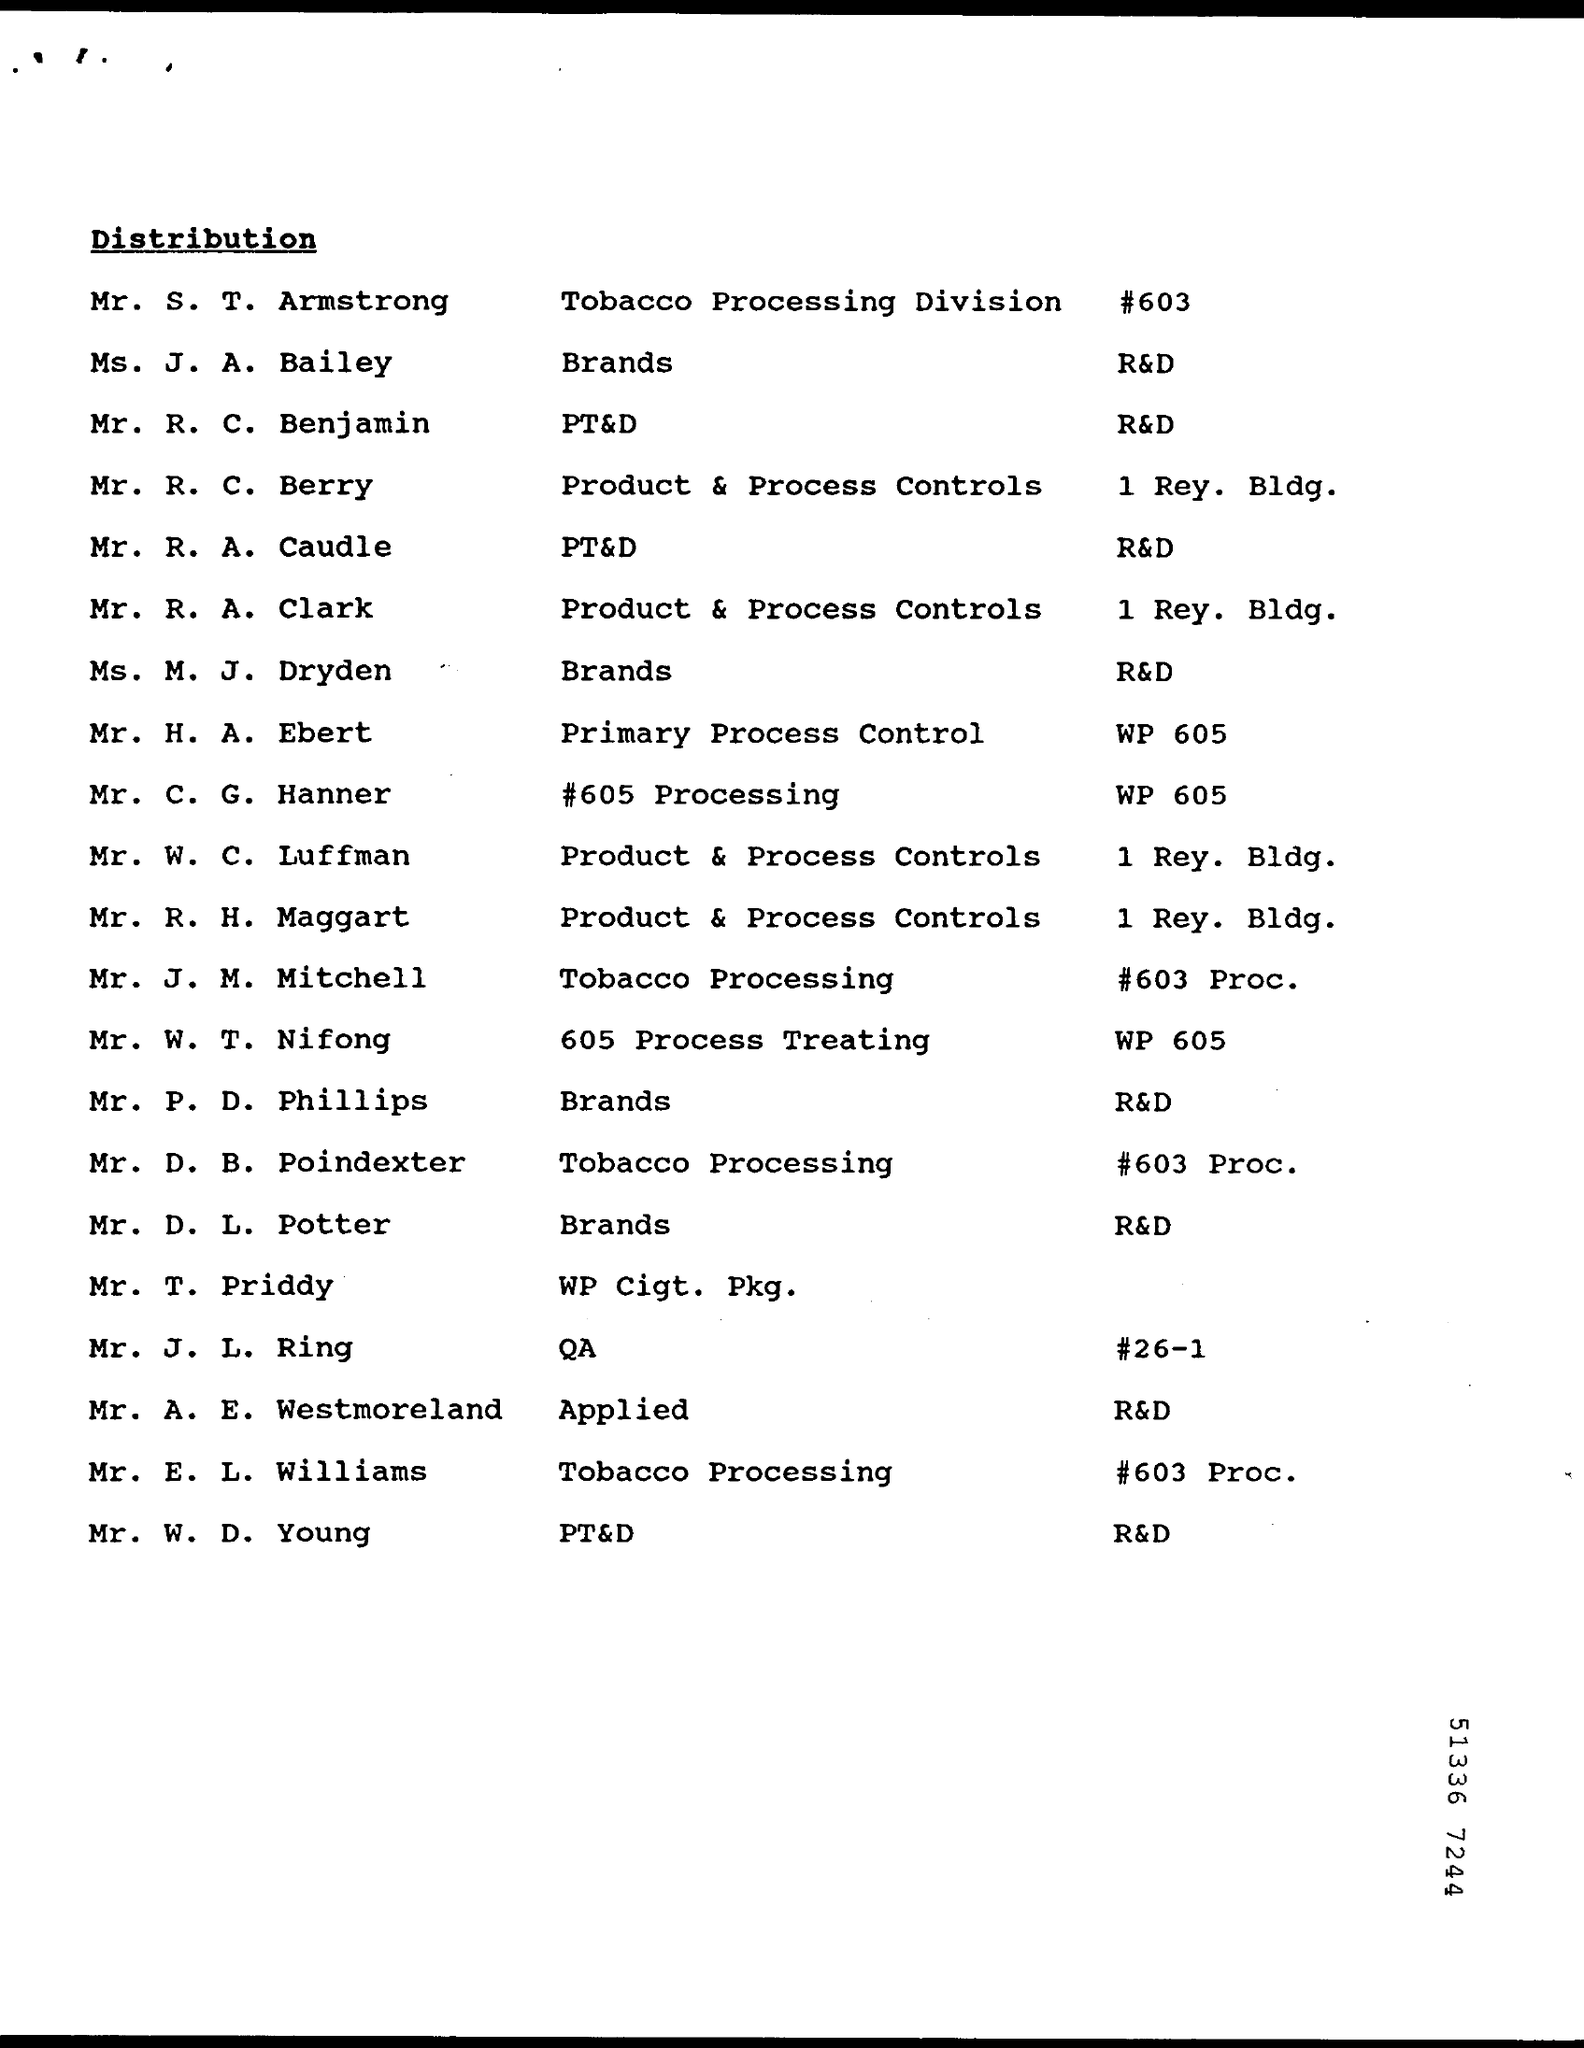Who is dealing with Tobacco Processing Division?
Give a very brief answer. Mr. S. T. Armstrong. What is the duty of Mr. R. A. Clark?
Provide a short and direct response. Product & Process Controls. 